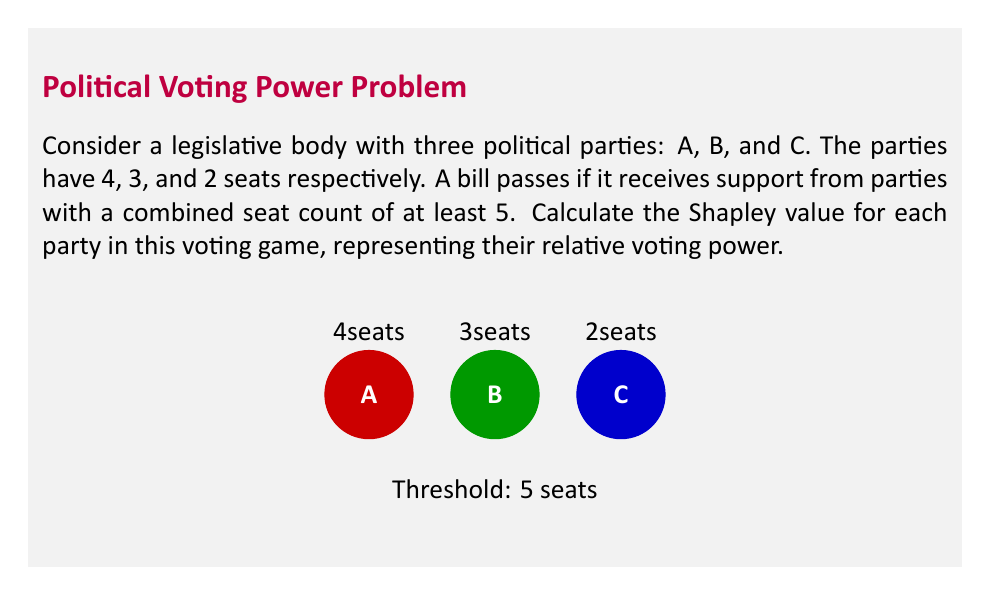Provide a solution to this math problem. To calculate the Shapley value, we need to consider all possible orderings of the parties and determine their marginal contributions. There are 3! = 6 possible orderings.

1) First, identify the winning coalitions:
   {A,B}, {A,C}, {A,B,C}

2) For each ordering, determine the pivotal player (the one whose addition makes the coalition winning):

   ABC: A is pivotal
   ACB: A is pivotal
   BAC: B is pivotal
   BCA: A is pivotal
   CAB: A is pivotal
   CBA: B is pivotal

3) Calculate the Shapley value for each party:

   Party A: Pivotal in 4 out of 6 orderings
   $\phi_A = \frac{4}{6} = \frac{2}{3}$

   Party B: Pivotal in 2 out of 6 orderings
   $\phi_B = \frac{2}{6} = \frac{1}{3}$

   Party C: Pivotal in 0 out of 6 orderings
   $\phi_C = \frac{0}{6} = 0$

4) Verify that the Shapley values sum to 1:
   $\phi_A + \phi_B + \phi_C = \frac{2}{3} + \frac{1}{3} + 0 = 1$

The Shapley values represent the proportion of orderings in which each party is pivotal, indicating their relative voting power in the legislative body.
Answer: $\phi_A = \frac{2}{3}$, $\phi_B = \frac{1}{3}$, $\phi_C = 0$ 